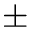<formula> <loc_0><loc_0><loc_500><loc_500>\pm</formula> 